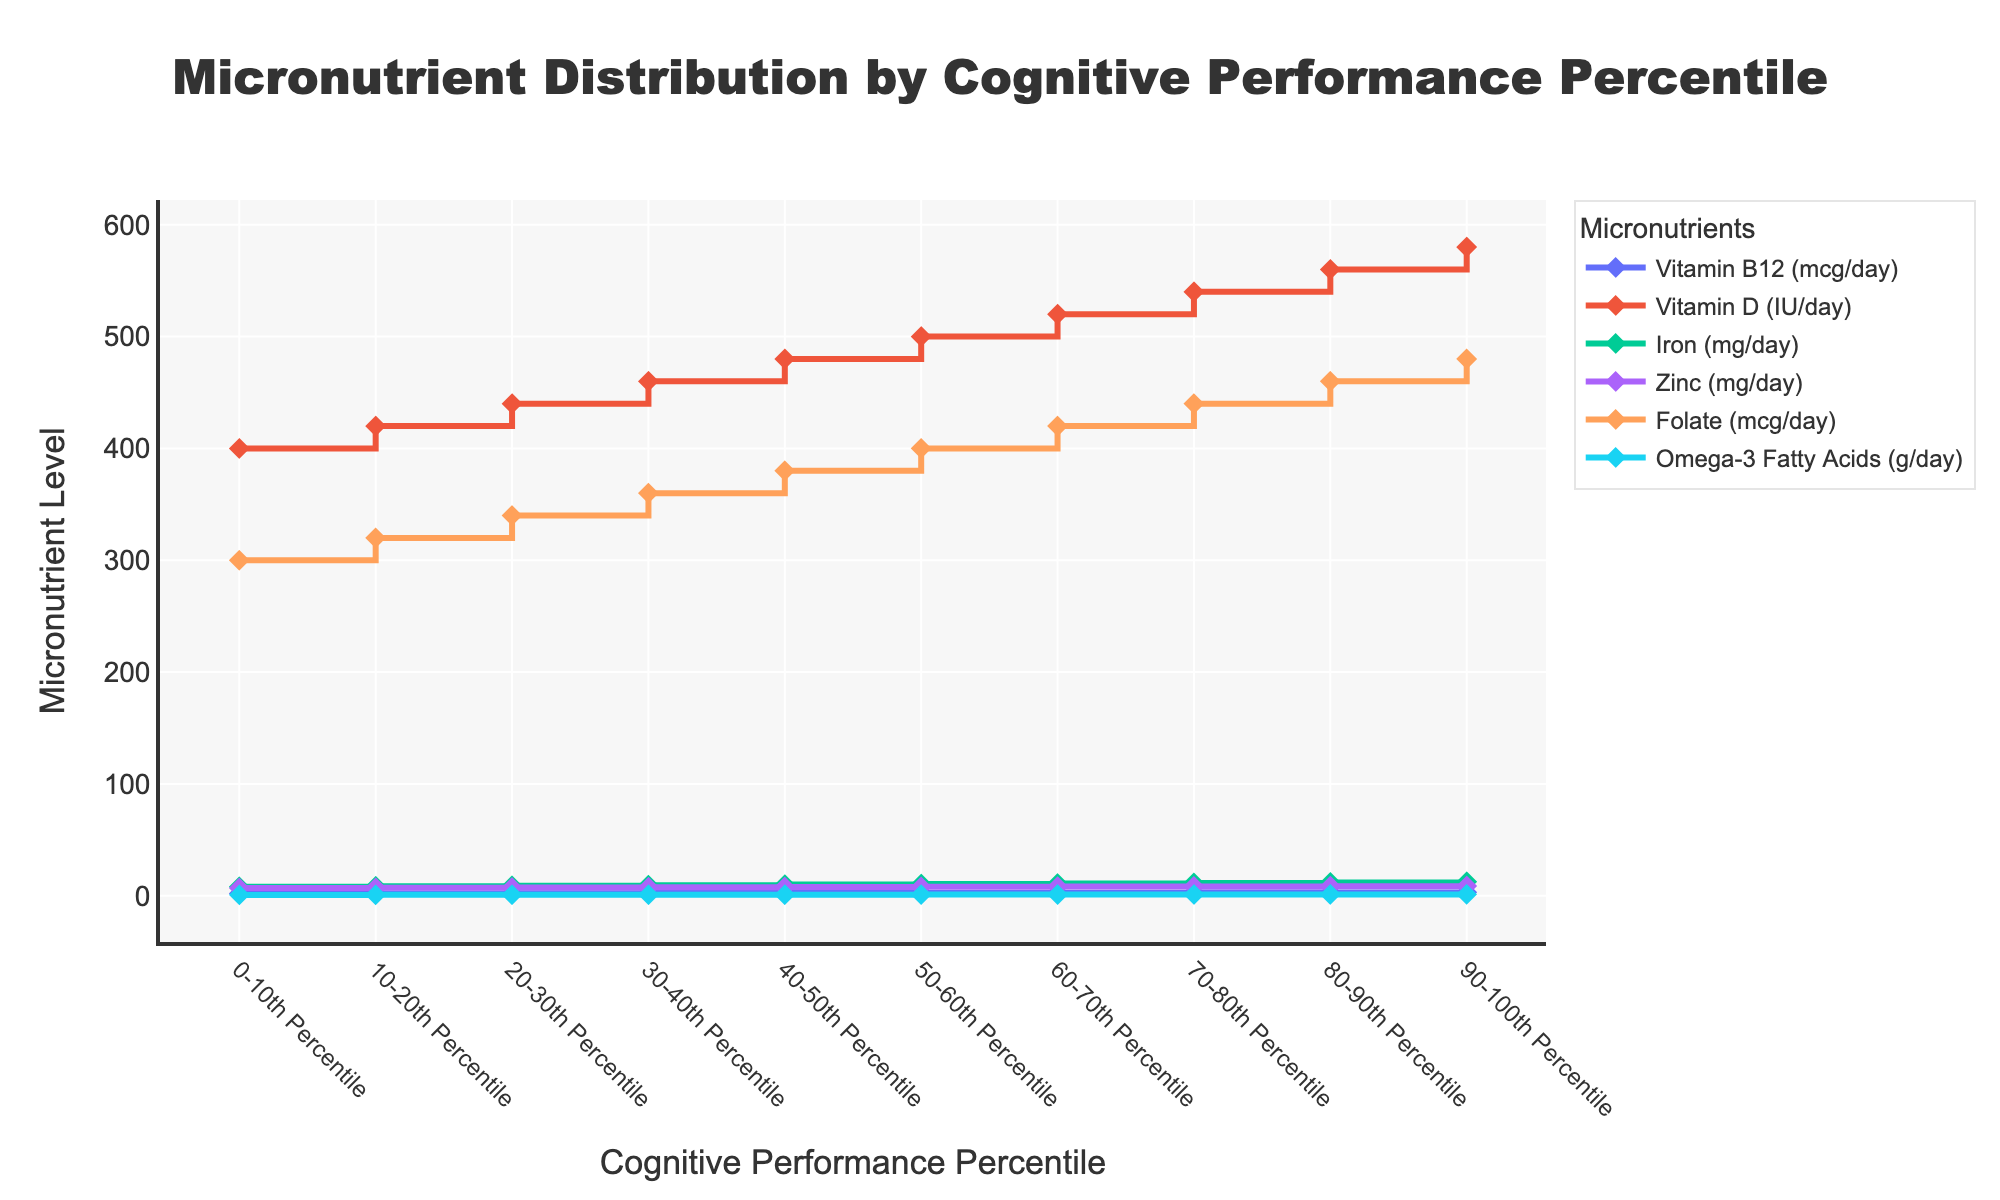How is the Y-axis labeled? The Y-axis in the stair plot represents the level of various micronutrients, as indicated by the title "Micronutrient Level". Different micronutrients are measured in different units like mcg/day, IU/day, mg/day, and g/day.
Answer: Micronutrient Level Which cognitive performance percentile consumes the highest amount of Iron? To determine this, look for the highest data point on the line representing Iron (mg/day). The 90-100th percentile for Iron consumption is 12.5 mg/day, which is the highest value.
Answer: 90-100th percentile What's the difference in average daily Vitamin D intake between the 0-10th percentile and the 90-100th percentile? The values for Vitamin D (IU/day) in the 0-10th and 90-100th percentiles are 400 IU and 580 IU respectively. The difference is calculated as 580 - 400 = 180 IU/day.
Answer: 180 IU Which micronutrient shows the least amount of variation across all percentiles? To answer this, observe the spread of values for each micronutrient across all percentiles. Zinc intake ranges from 7.0 mg/day to 8.8 mg/day. This is the smallest variation compared to other micronutrients.
Answer: Zinc How does the intake of Omega-3 Fatty Acids change from the 0-10th percentile to the 50-60th percentile? From the 0-10th percentile to the 50-60th percentile, Omega-3 Fatty Acids intake increases from 0.8 g/day to 1.05 g/day. The incremental steps consistently rise by 0.05 g/day for each percentile increase.
Answer: Increases What's the median daily Folate intake value for the given percentiles? To find the median, observe the values in ascending order and locate the middle value. The middle-two percentiles are 40-50th and 50-60th which are 380 mcg/day and 400 mcg/day respectively. The median is (380+400)/2 = 390 mcg/day.
Answer: 390 mcg/day Which micronutrient shows the greatest increase from the 30-40th to the 90-100th percentile? To analyze this, compare the increase in values from the 30-40th to the 90-100th percentile for all micronutrients. The greatest increase is seen in Iron, which increases from 9.5 mg/day to 12.5 mg/day, a change of 3.0 mg/day.
Answer: Iron Are there any micronutrients that show a linear increase across all percentiles? A linear increase can be determined if the values increase consistently at a constant rate across all percentiles. In this case, Vitamin D shows a linear increase where each percentile increment corresponds to a 20 IU/day increase.
Answer: Yes, Vitamin D 